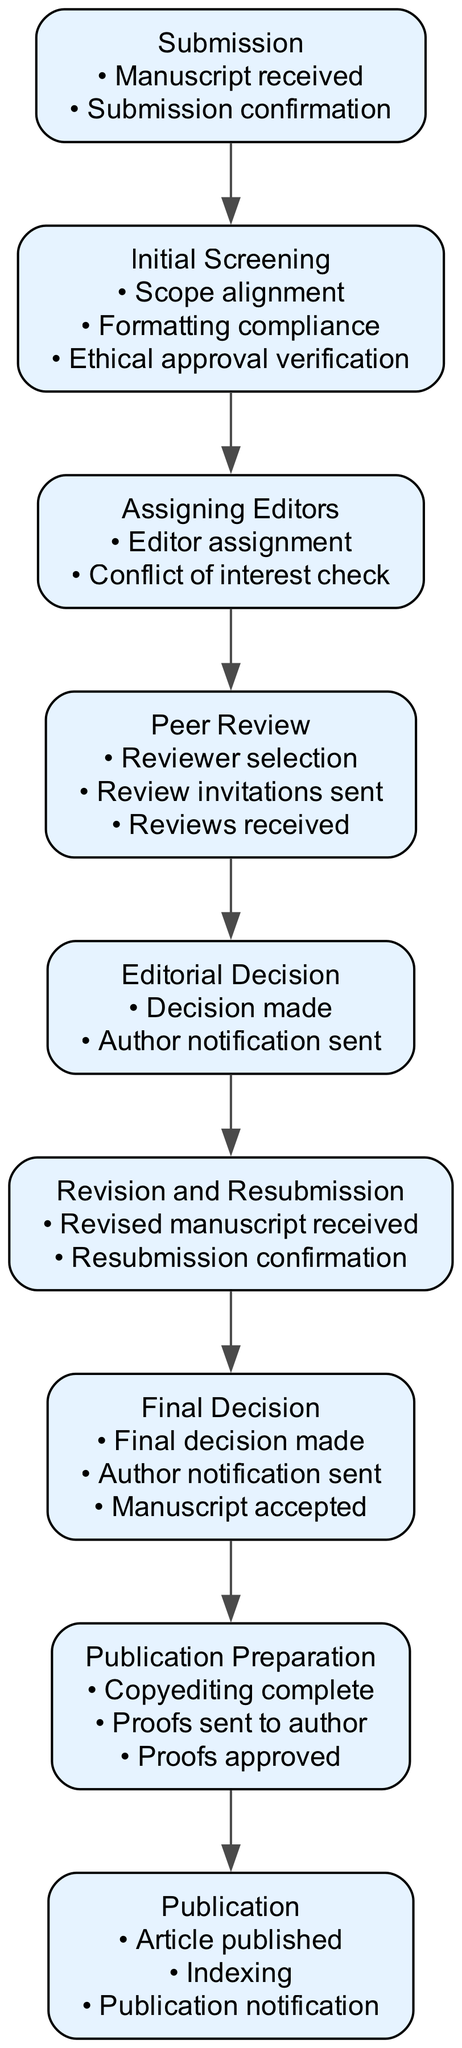What is the first step in the peer review process? The diagram indicates that the first step is "Submission," where authors submit their manuscript.
Answer: Submission How many milestones are listed under the "Initial Screening"? There are three milestones noted in the "Initial Screening" step: "Scope alignment," "Formatting compliance," and "Ethical approval verification."
Answer: Three Which step comes after "Peer Review"? The diagram shows that the step following "Peer Review" is "Editorial Decision," where the associate editor makes a decision based on reviewer feedback.
Answer: Editorial Decision What key action occurs in the "Revision and Resubmission" step? In the "Revision and Resubmission" step, authors revise their manuscript based on feedback and resubmit it.
Answer: Authors revise and resubmit What is the last milestone in the "Publication" step? The final milestone listed in the "Publication" step is "Publication notification," which indicates the communication sent out once the work is published.
Answer: Publication notification How does "Assigning Editors" relate to "Initial Screening"? "Assigning Editors" follows "Initial Screening," indicating a sequential process where editors are assigned after the initial checks are complete.
Answer: Sequential process What action is taken based on reviewer feedback in the "Editorial Decision" step? The associate editor makes a decision to accept, revise, or reject the manuscript based on the feedback received from reviewers.
Answer: Decision made How many steps are in the overall peer review process? The diagram presents a total of nine steps outlining the entire peer review process from submission to publication.
Answer: Nine 